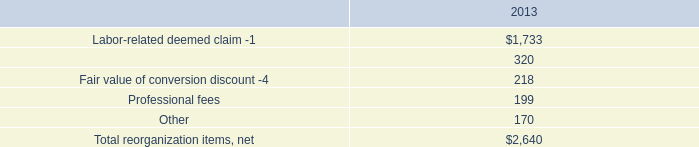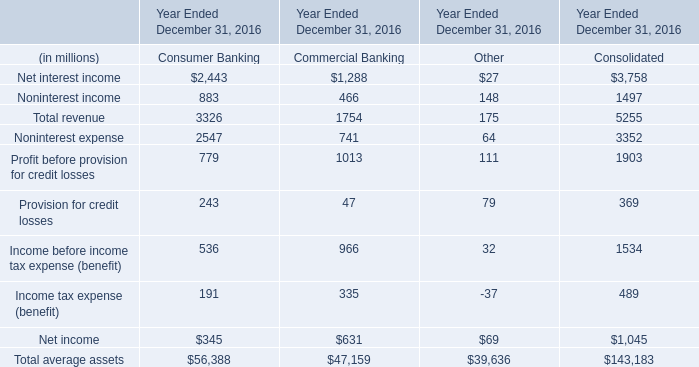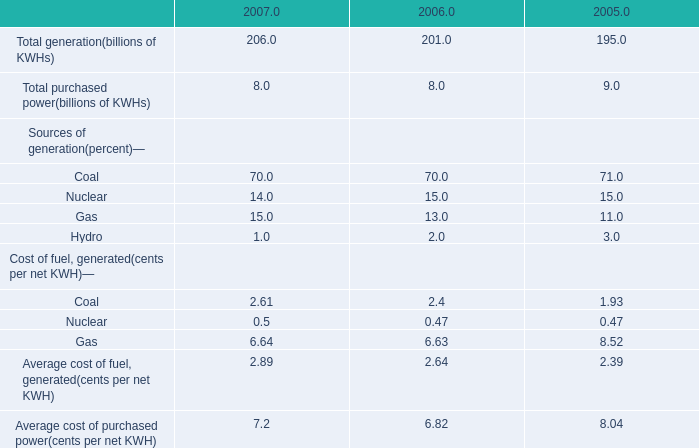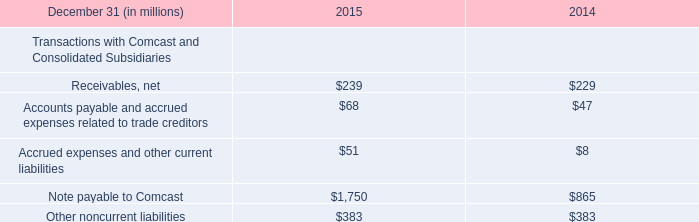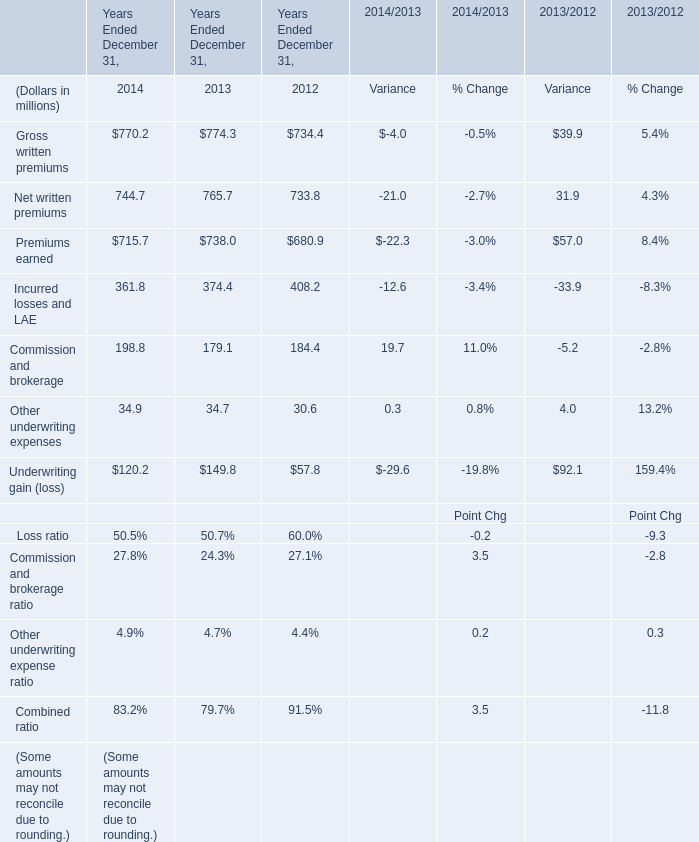What was the average value of the Underwriting gain (loss) in the years where Net written premiums is positive? (in million) 
Computations: (((120.2 + 149.8) + 57.8) / 3)
Answer: 109.26667. 